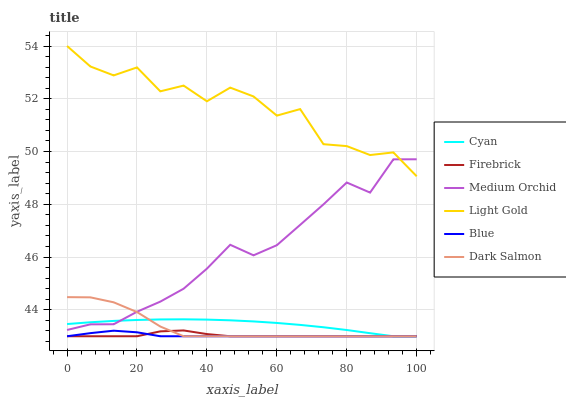Does Blue have the minimum area under the curve?
Answer yes or no. Yes. Does Light Gold have the maximum area under the curve?
Answer yes or no. Yes. Does Firebrick have the minimum area under the curve?
Answer yes or no. No. Does Firebrick have the maximum area under the curve?
Answer yes or no. No. Is Cyan the smoothest?
Answer yes or no. Yes. Is Light Gold the roughest?
Answer yes or no. Yes. Is Firebrick the smoothest?
Answer yes or no. No. Is Firebrick the roughest?
Answer yes or no. No. Does Blue have the lowest value?
Answer yes or no. Yes. Does Medium Orchid have the lowest value?
Answer yes or no. No. Does Light Gold have the highest value?
Answer yes or no. Yes. Does Firebrick have the highest value?
Answer yes or no. No. Is Blue less than Light Gold?
Answer yes or no. Yes. Is Medium Orchid greater than Firebrick?
Answer yes or no. Yes. Does Light Gold intersect Medium Orchid?
Answer yes or no. Yes. Is Light Gold less than Medium Orchid?
Answer yes or no. No. Is Light Gold greater than Medium Orchid?
Answer yes or no. No. Does Blue intersect Light Gold?
Answer yes or no. No. 